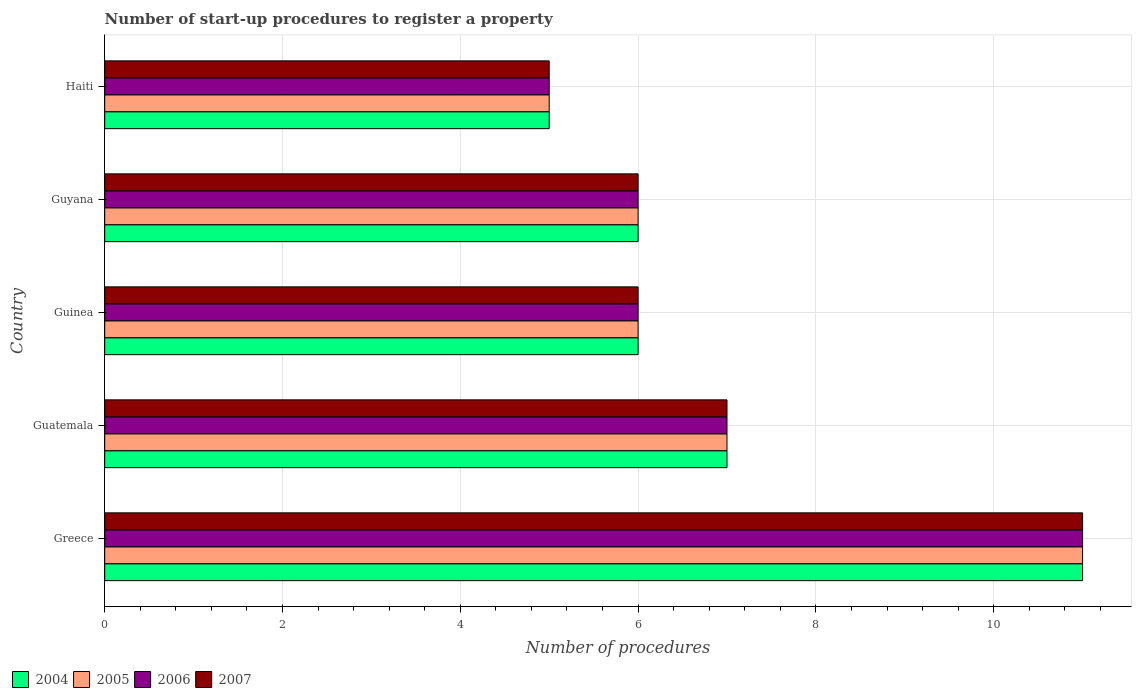How many bars are there on the 2nd tick from the bottom?
Make the answer very short. 4. What is the label of the 2nd group of bars from the top?
Give a very brief answer. Guyana. In how many cases, is the number of bars for a given country not equal to the number of legend labels?
Provide a succinct answer. 0. What is the number of procedures required to register a property in 2006 in Guyana?
Provide a succinct answer. 6. In which country was the number of procedures required to register a property in 2005 maximum?
Provide a short and direct response. Greece. In which country was the number of procedures required to register a property in 2004 minimum?
Ensure brevity in your answer.  Haiti. What is the average number of procedures required to register a property in 2004 per country?
Your answer should be compact. 7. What is the difference between the number of procedures required to register a property in 2005 and number of procedures required to register a property in 2006 in Guyana?
Provide a short and direct response. 0. What is the ratio of the number of procedures required to register a property in 2007 in Guinea to that in Haiti?
Provide a succinct answer. 1.2. Is the number of procedures required to register a property in 2004 in Greece less than that in Guinea?
Offer a terse response. No. What is the difference between the highest and the lowest number of procedures required to register a property in 2004?
Give a very brief answer. 6. In how many countries, is the number of procedures required to register a property in 2005 greater than the average number of procedures required to register a property in 2005 taken over all countries?
Your response must be concise. 1. Is the sum of the number of procedures required to register a property in 2006 in Greece and Haiti greater than the maximum number of procedures required to register a property in 2007 across all countries?
Your answer should be very brief. Yes. What does the 4th bar from the top in Haiti represents?
Give a very brief answer. 2004. Is it the case that in every country, the sum of the number of procedures required to register a property in 2005 and number of procedures required to register a property in 2006 is greater than the number of procedures required to register a property in 2004?
Offer a terse response. Yes. How many bars are there?
Keep it short and to the point. 20. Are the values on the major ticks of X-axis written in scientific E-notation?
Give a very brief answer. No. What is the title of the graph?
Make the answer very short. Number of start-up procedures to register a property. Does "1978" appear as one of the legend labels in the graph?
Offer a terse response. No. What is the label or title of the X-axis?
Offer a very short reply. Number of procedures. What is the label or title of the Y-axis?
Make the answer very short. Country. What is the Number of procedures in 2004 in Greece?
Your response must be concise. 11. What is the Number of procedures of 2006 in Greece?
Provide a short and direct response. 11. What is the Number of procedures in 2007 in Greece?
Your answer should be very brief. 11. What is the Number of procedures in 2007 in Guatemala?
Ensure brevity in your answer.  7. What is the Number of procedures in 2005 in Guinea?
Give a very brief answer. 6. What is the Number of procedures of 2007 in Guinea?
Make the answer very short. 6. What is the Number of procedures of 2005 in Guyana?
Make the answer very short. 6. What is the Number of procedures of 2006 in Guyana?
Make the answer very short. 6. What is the Number of procedures of 2007 in Haiti?
Offer a very short reply. 5. Across all countries, what is the maximum Number of procedures in 2005?
Your answer should be compact. 11. Across all countries, what is the maximum Number of procedures in 2006?
Offer a terse response. 11. Across all countries, what is the minimum Number of procedures in 2005?
Give a very brief answer. 5. What is the total Number of procedures in 2005 in the graph?
Keep it short and to the point. 35. What is the total Number of procedures of 2007 in the graph?
Give a very brief answer. 35. What is the difference between the Number of procedures in 2004 in Greece and that in Guatemala?
Your answer should be compact. 4. What is the difference between the Number of procedures in 2005 in Greece and that in Guatemala?
Your answer should be compact. 4. What is the difference between the Number of procedures in 2004 in Greece and that in Guinea?
Keep it short and to the point. 5. What is the difference between the Number of procedures in 2004 in Greece and that in Guyana?
Keep it short and to the point. 5. What is the difference between the Number of procedures in 2006 in Greece and that in Guyana?
Provide a succinct answer. 5. What is the difference between the Number of procedures of 2007 in Greece and that in Guyana?
Keep it short and to the point. 5. What is the difference between the Number of procedures in 2004 in Greece and that in Haiti?
Offer a very short reply. 6. What is the difference between the Number of procedures of 2005 in Greece and that in Haiti?
Provide a short and direct response. 6. What is the difference between the Number of procedures in 2004 in Guatemala and that in Guinea?
Provide a succinct answer. 1. What is the difference between the Number of procedures of 2005 in Guatemala and that in Guinea?
Offer a very short reply. 1. What is the difference between the Number of procedures of 2006 in Guatemala and that in Guinea?
Give a very brief answer. 1. What is the difference between the Number of procedures in 2007 in Guatemala and that in Guinea?
Give a very brief answer. 1. What is the difference between the Number of procedures of 2005 in Guatemala and that in Guyana?
Your answer should be very brief. 1. What is the difference between the Number of procedures of 2006 in Guatemala and that in Guyana?
Keep it short and to the point. 1. What is the difference between the Number of procedures in 2007 in Guatemala and that in Guyana?
Ensure brevity in your answer.  1. What is the difference between the Number of procedures in 2004 in Guinea and that in Guyana?
Make the answer very short. 0. What is the difference between the Number of procedures in 2005 in Guinea and that in Guyana?
Your response must be concise. 0. What is the difference between the Number of procedures of 2004 in Guinea and that in Haiti?
Your response must be concise. 1. What is the difference between the Number of procedures of 2007 in Guinea and that in Haiti?
Your response must be concise. 1. What is the difference between the Number of procedures in 2007 in Guyana and that in Haiti?
Provide a short and direct response. 1. What is the difference between the Number of procedures of 2004 in Greece and the Number of procedures of 2006 in Guatemala?
Provide a short and direct response. 4. What is the difference between the Number of procedures of 2004 in Greece and the Number of procedures of 2005 in Guinea?
Offer a very short reply. 5. What is the difference between the Number of procedures of 2004 in Greece and the Number of procedures of 2006 in Guinea?
Provide a succinct answer. 5. What is the difference between the Number of procedures in 2005 in Greece and the Number of procedures in 2006 in Guinea?
Make the answer very short. 5. What is the difference between the Number of procedures of 2004 in Greece and the Number of procedures of 2006 in Guyana?
Make the answer very short. 5. What is the difference between the Number of procedures in 2004 in Greece and the Number of procedures in 2007 in Guyana?
Provide a succinct answer. 5. What is the difference between the Number of procedures of 2006 in Greece and the Number of procedures of 2007 in Guyana?
Ensure brevity in your answer.  5. What is the difference between the Number of procedures in 2004 in Greece and the Number of procedures in 2005 in Haiti?
Your answer should be compact. 6. What is the difference between the Number of procedures of 2004 in Greece and the Number of procedures of 2006 in Haiti?
Offer a very short reply. 6. What is the difference between the Number of procedures in 2005 in Greece and the Number of procedures in 2006 in Haiti?
Offer a terse response. 6. What is the difference between the Number of procedures in 2005 in Greece and the Number of procedures in 2007 in Haiti?
Provide a short and direct response. 6. What is the difference between the Number of procedures in 2004 in Guatemala and the Number of procedures in 2005 in Guinea?
Make the answer very short. 1. What is the difference between the Number of procedures in 2004 in Guatemala and the Number of procedures in 2007 in Guinea?
Your answer should be compact. 1. What is the difference between the Number of procedures in 2005 in Guatemala and the Number of procedures in 2007 in Guinea?
Give a very brief answer. 1. What is the difference between the Number of procedures in 2004 in Guatemala and the Number of procedures in 2006 in Guyana?
Your answer should be very brief. 1. What is the difference between the Number of procedures in 2006 in Guatemala and the Number of procedures in 2007 in Guyana?
Make the answer very short. 1. What is the difference between the Number of procedures in 2004 in Guatemala and the Number of procedures in 2005 in Haiti?
Make the answer very short. 2. What is the difference between the Number of procedures of 2004 in Guatemala and the Number of procedures of 2006 in Haiti?
Ensure brevity in your answer.  2. What is the difference between the Number of procedures of 2004 in Guatemala and the Number of procedures of 2007 in Haiti?
Your answer should be very brief. 2. What is the difference between the Number of procedures of 2005 in Guatemala and the Number of procedures of 2007 in Haiti?
Offer a terse response. 2. What is the difference between the Number of procedures in 2006 in Guatemala and the Number of procedures in 2007 in Haiti?
Provide a succinct answer. 2. What is the difference between the Number of procedures of 2004 in Guinea and the Number of procedures of 2005 in Guyana?
Keep it short and to the point. 0. What is the difference between the Number of procedures of 2005 in Guinea and the Number of procedures of 2007 in Guyana?
Ensure brevity in your answer.  0. What is the difference between the Number of procedures in 2004 in Guinea and the Number of procedures in 2006 in Haiti?
Offer a terse response. 1. What is the difference between the Number of procedures of 2005 in Guinea and the Number of procedures of 2006 in Haiti?
Provide a succinct answer. 1. What is the difference between the Number of procedures in 2004 in Guyana and the Number of procedures in 2006 in Haiti?
Give a very brief answer. 1. What is the difference between the Number of procedures of 2004 in Guyana and the Number of procedures of 2007 in Haiti?
Offer a very short reply. 1. What is the difference between the Number of procedures of 2005 in Guyana and the Number of procedures of 2006 in Haiti?
Give a very brief answer. 1. What is the difference between the Number of procedures of 2005 in Guyana and the Number of procedures of 2007 in Haiti?
Give a very brief answer. 1. What is the difference between the Number of procedures in 2006 in Guyana and the Number of procedures in 2007 in Haiti?
Offer a very short reply. 1. What is the average Number of procedures of 2007 per country?
Provide a short and direct response. 7. What is the difference between the Number of procedures of 2004 and Number of procedures of 2005 in Greece?
Give a very brief answer. 0. What is the difference between the Number of procedures of 2004 and Number of procedures of 2006 in Greece?
Your answer should be very brief. 0. What is the difference between the Number of procedures in 2004 and Number of procedures in 2007 in Greece?
Your answer should be compact. 0. What is the difference between the Number of procedures of 2005 and Number of procedures of 2006 in Greece?
Ensure brevity in your answer.  0. What is the difference between the Number of procedures in 2004 and Number of procedures in 2007 in Guatemala?
Give a very brief answer. 0. What is the difference between the Number of procedures of 2005 and Number of procedures of 2006 in Guatemala?
Give a very brief answer. 0. What is the difference between the Number of procedures of 2004 and Number of procedures of 2005 in Guinea?
Provide a short and direct response. 0. What is the difference between the Number of procedures of 2004 and Number of procedures of 2006 in Guinea?
Ensure brevity in your answer.  0. What is the difference between the Number of procedures of 2005 and Number of procedures of 2006 in Guinea?
Offer a very short reply. 0. What is the difference between the Number of procedures in 2006 and Number of procedures in 2007 in Guinea?
Offer a very short reply. 0. What is the difference between the Number of procedures in 2004 and Number of procedures in 2005 in Guyana?
Make the answer very short. 0. What is the difference between the Number of procedures in 2004 and Number of procedures in 2006 in Guyana?
Provide a succinct answer. 0. What is the difference between the Number of procedures in 2004 and Number of procedures in 2007 in Guyana?
Offer a terse response. 0. What is the difference between the Number of procedures in 2005 and Number of procedures in 2006 in Guyana?
Keep it short and to the point. 0. What is the difference between the Number of procedures in 2005 and Number of procedures in 2007 in Guyana?
Offer a very short reply. 0. What is the difference between the Number of procedures of 2006 and Number of procedures of 2007 in Guyana?
Provide a short and direct response. 0. What is the difference between the Number of procedures in 2004 and Number of procedures in 2005 in Haiti?
Your response must be concise. 0. What is the difference between the Number of procedures in 2004 and Number of procedures in 2006 in Haiti?
Provide a succinct answer. 0. What is the difference between the Number of procedures in 2004 and Number of procedures in 2007 in Haiti?
Offer a very short reply. 0. What is the difference between the Number of procedures of 2005 and Number of procedures of 2006 in Haiti?
Make the answer very short. 0. What is the difference between the Number of procedures of 2006 and Number of procedures of 2007 in Haiti?
Ensure brevity in your answer.  0. What is the ratio of the Number of procedures of 2004 in Greece to that in Guatemala?
Keep it short and to the point. 1.57. What is the ratio of the Number of procedures of 2005 in Greece to that in Guatemala?
Your answer should be compact. 1.57. What is the ratio of the Number of procedures in 2006 in Greece to that in Guatemala?
Provide a short and direct response. 1.57. What is the ratio of the Number of procedures of 2007 in Greece to that in Guatemala?
Provide a short and direct response. 1.57. What is the ratio of the Number of procedures of 2004 in Greece to that in Guinea?
Provide a succinct answer. 1.83. What is the ratio of the Number of procedures of 2005 in Greece to that in Guinea?
Offer a terse response. 1.83. What is the ratio of the Number of procedures in 2006 in Greece to that in Guinea?
Provide a succinct answer. 1.83. What is the ratio of the Number of procedures in 2007 in Greece to that in Guinea?
Your answer should be very brief. 1.83. What is the ratio of the Number of procedures in 2004 in Greece to that in Guyana?
Offer a very short reply. 1.83. What is the ratio of the Number of procedures in 2005 in Greece to that in Guyana?
Your answer should be very brief. 1.83. What is the ratio of the Number of procedures in 2006 in Greece to that in Guyana?
Provide a short and direct response. 1.83. What is the ratio of the Number of procedures of 2007 in Greece to that in Guyana?
Your answer should be compact. 1.83. What is the ratio of the Number of procedures of 2005 in Greece to that in Haiti?
Your response must be concise. 2.2. What is the ratio of the Number of procedures of 2006 in Greece to that in Haiti?
Your answer should be compact. 2.2. What is the ratio of the Number of procedures of 2004 in Guatemala to that in Guinea?
Your response must be concise. 1.17. What is the ratio of the Number of procedures of 2005 in Guatemala to that in Guinea?
Offer a very short reply. 1.17. What is the ratio of the Number of procedures of 2006 in Guatemala to that in Guinea?
Give a very brief answer. 1.17. What is the ratio of the Number of procedures of 2006 in Guatemala to that in Guyana?
Keep it short and to the point. 1.17. What is the ratio of the Number of procedures in 2007 in Guatemala to that in Guyana?
Offer a very short reply. 1.17. What is the ratio of the Number of procedures in 2004 in Guatemala to that in Haiti?
Your answer should be very brief. 1.4. What is the ratio of the Number of procedures in 2006 in Guatemala to that in Haiti?
Give a very brief answer. 1.4. What is the ratio of the Number of procedures in 2006 in Guinea to that in Guyana?
Ensure brevity in your answer.  1. What is the ratio of the Number of procedures in 2007 in Guinea to that in Haiti?
Your answer should be very brief. 1.2. What is the ratio of the Number of procedures in 2005 in Guyana to that in Haiti?
Keep it short and to the point. 1.2. What is the ratio of the Number of procedures in 2006 in Guyana to that in Haiti?
Give a very brief answer. 1.2. What is the difference between the highest and the second highest Number of procedures of 2004?
Make the answer very short. 4. What is the difference between the highest and the second highest Number of procedures in 2007?
Keep it short and to the point. 4. What is the difference between the highest and the lowest Number of procedures in 2005?
Your answer should be compact. 6. 